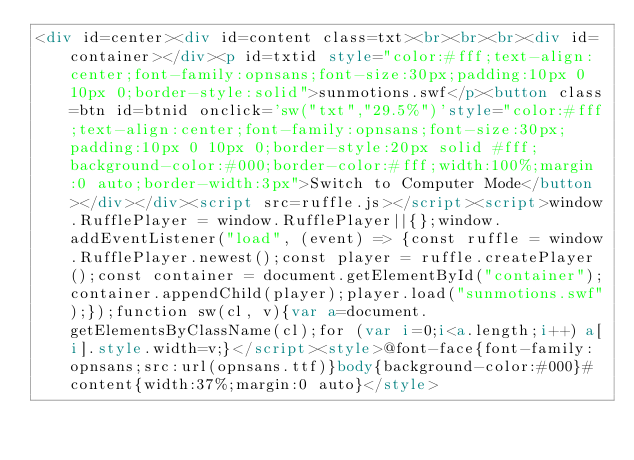<code> <loc_0><loc_0><loc_500><loc_500><_HTML_><div id=center><div id=content class=txt><br><br><br><div id=container></div><p id=txtid style="color:#fff;text-align:center;font-family:opnsans;font-size:30px;padding:10px 0 10px 0;border-style:solid">sunmotions.swf</p><button class=btn id=btnid onclick='sw("txt","29.5%")'style="color:#fff;text-align:center;font-family:opnsans;font-size:30px;padding:10px 0 10px 0;border-style:20px solid #fff;background-color:#000;border-color:#fff;width:100%;margin:0 auto;border-width:3px">Switch to Computer Mode</button></div></div><script src=ruffle.js></script><script>window.RufflePlayer = window.RufflePlayer||{};window.addEventListener("load", (event) => {const ruffle = window.RufflePlayer.newest();const player = ruffle.createPlayer();const container = document.getElementById("container");container.appendChild(player);player.load("sunmotions.swf");});function sw(cl, v){var a=document.getElementsByClassName(cl);for (var i=0;i<a.length;i++) a[i].style.width=v;}</script><style>@font-face{font-family:opnsans;src:url(opnsans.ttf)}body{background-color:#000}#content{width:37%;margin:0 auto}</style>
</code> 